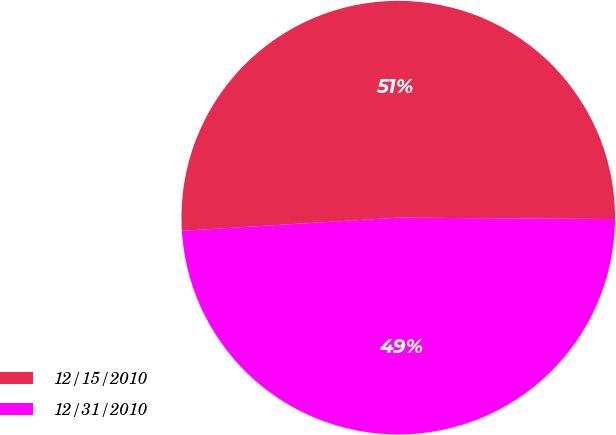Convert chart to OTSL. <chart><loc_0><loc_0><loc_500><loc_500><pie_chart><fcel>12/15/2010<fcel>12/31/2010<nl><fcel>51.07%<fcel>48.93%<nl></chart> 